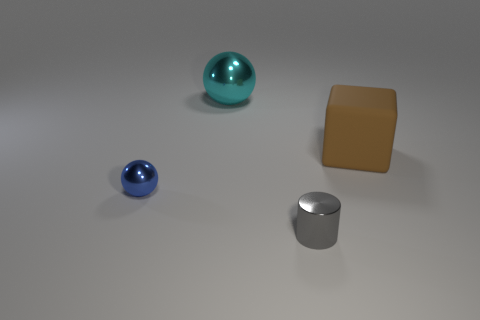Do the brown matte thing and the blue object have the same size?
Offer a terse response. No. There is a thing to the left of the big ball; what is its shape?
Your answer should be compact. Sphere. There is a large thing on the right side of the cyan metal object behind the big brown block; what color is it?
Your answer should be compact. Brown. Does the small metal thing that is in front of the blue object have the same shape as the shiny thing that is behind the brown thing?
Keep it short and to the point. No. The brown rubber object that is the same size as the cyan thing is what shape?
Keep it short and to the point. Cube. What is the color of the small cylinder that is made of the same material as the large ball?
Make the answer very short. Gray. There is a large cyan shiny thing; is it the same shape as the object that is left of the cyan object?
Make the answer very short. Yes. There is a object that is the same size as the cyan sphere; what is its material?
Your answer should be compact. Rubber. Is there a metal object of the same color as the tiny ball?
Offer a terse response. No. There is a object that is both behind the small shiny sphere and to the left of the big brown rubber thing; what is its shape?
Give a very brief answer. Sphere. 